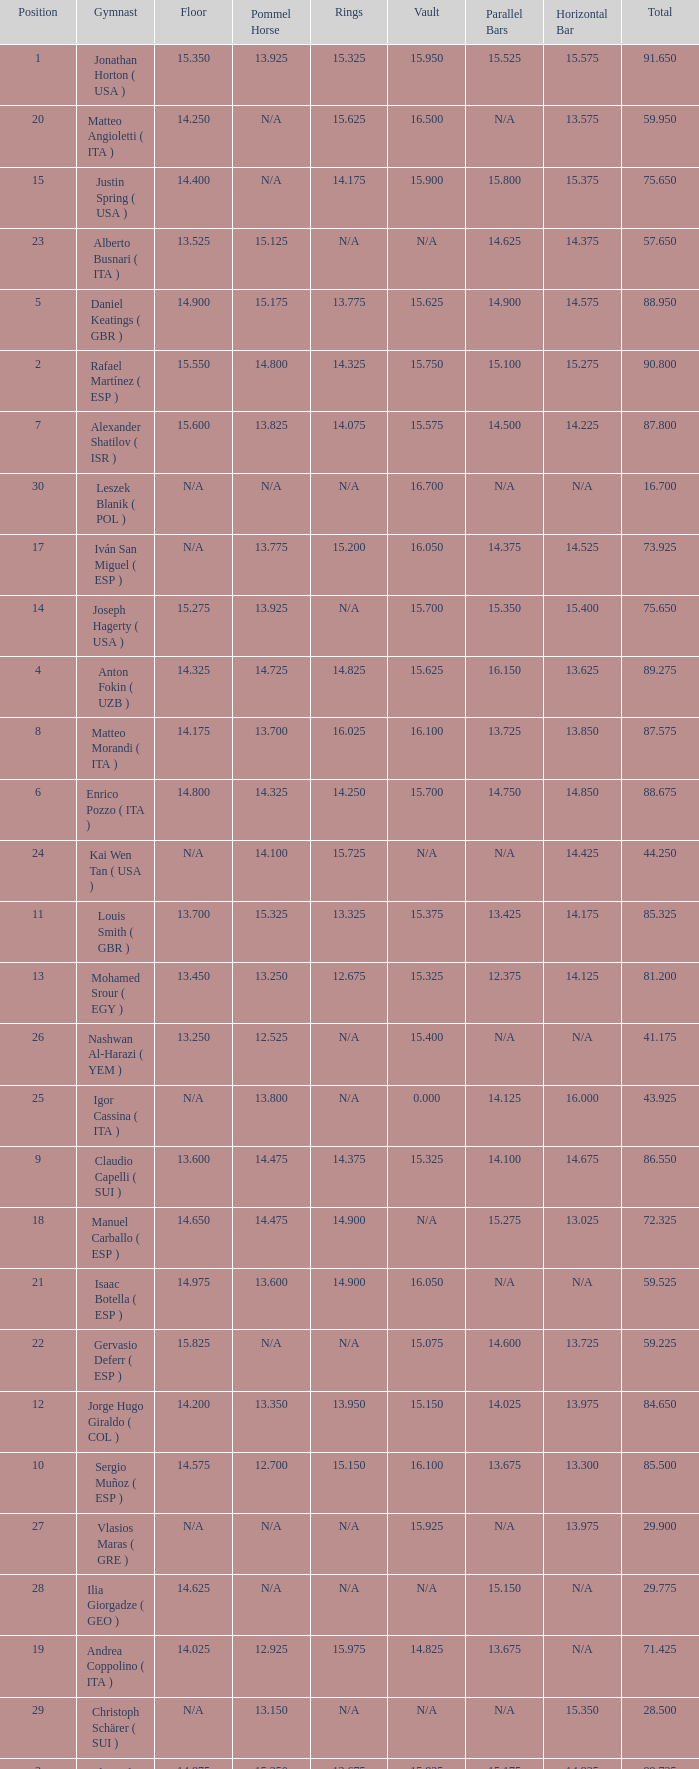If the horizontal bar is n/a and the floor is 14.175, what is the number for the parallel bars? 15.625. 